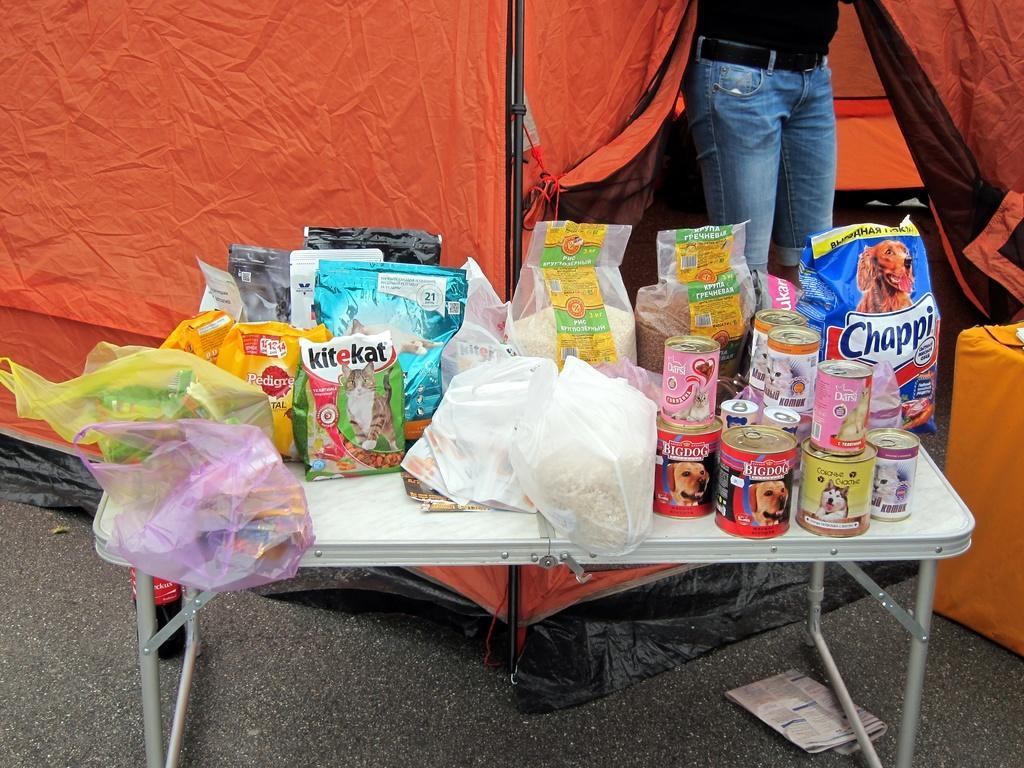Describe this image in one or two sentences. Here I can see a table on which bottles and some packets are placed. At the bottom there is a newspaper on the floor. In the background there is a tent and I can see a person is standing. On the right side there is an orange color object. 